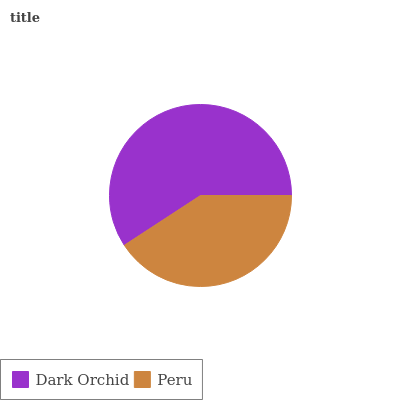Is Peru the minimum?
Answer yes or no. Yes. Is Dark Orchid the maximum?
Answer yes or no. Yes. Is Peru the maximum?
Answer yes or no. No. Is Dark Orchid greater than Peru?
Answer yes or no. Yes. Is Peru less than Dark Orchid?
Answer yes or no. Yes. Is Peru greater than Dark Orchid?
Answer yes or no. No. Is Dark Orchid less than Peru?
Answer yes or no. No. Is Dark Orchid the high median?
Answer yes or no. Yes. Is Peru the low median?
Answer yes or no. Yes. Is Peru the high median?
Answer yes or no. No. Is Dark Orchid the low median?
Answer yes or no. No. 